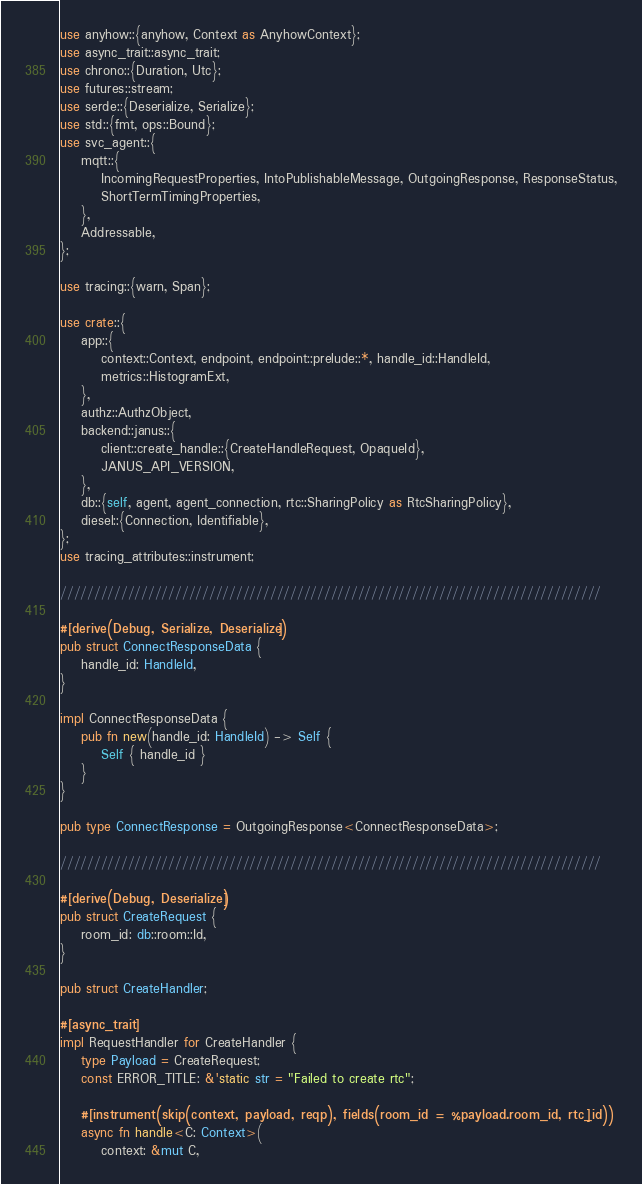Convert code to text. <code><loc_0><loc_0><loc_500><loc_500><_Rust_>use anyhow::{anyhow, Context as AnyhowContext};
use async_trait::async_trait;
use chrono::{Duration, Utc};
use futures::stream;
use serde::{Deserialize, Serialize};
use std::{fmt, ops::Bound};
use svc_agent::{
    mqtt::{
        IncomingRequestProperties, IntoPublishableMessage, OutgoingResponse, ResponseStatus,
        ShortTermTimingProperties,
    },
    Addressable,
};

use tracing::{warn, Span};

use crate::{
    app::{
        context::Context, endpoint, endpoint::prelude::*, handle_id::HandleId,
        metrics::HistogramExt,
    },
    authz::AuthzObject,
    backend::janus::{
        client::create_handle::{CreateHandleRequest, OpaqueId},
        JANUS_API_VERSION,
    },
    db::{self, agent, agent_connection, rtc::SharingPolicy as RtcSharingPolicy},
    diesel::{Connection, Identifiable},
};
use tracing_attributes::instrument;

////////////////////////////////////////////////////////////////////////////////

#[derive(Debug, Serialize, Deserialize)]
pub struct ConnectResponseData {
    handle_id: HandleId,
}

impl ConnectResponseData {
    pub fn new(handle_id: HandleId) -> Self {
        Self { handle_id }
    }
}

pub type ConnectResponse = OutgoingResponse<ConnectResponseData>;

////////////////////////////////////////////////////////////////////////////////

#[derive(Debug, Deserialize)]
pub struct CreateRequest {
    room_id: db::room::Id,
}

pub struct CreateHandler;

#[async_trait]
impl RequestHandler for CreateHandler {
    type Payload = CreateRequest;
    const ERROR_TITLE: &'static str = "Failed to create rtc";

    #[instrument(skip(context, payload, reqp), fields(room_id = %payload.room_id, rtc_id))]
    async fn handle<C: Context>(
        context: &mut C,</code> 